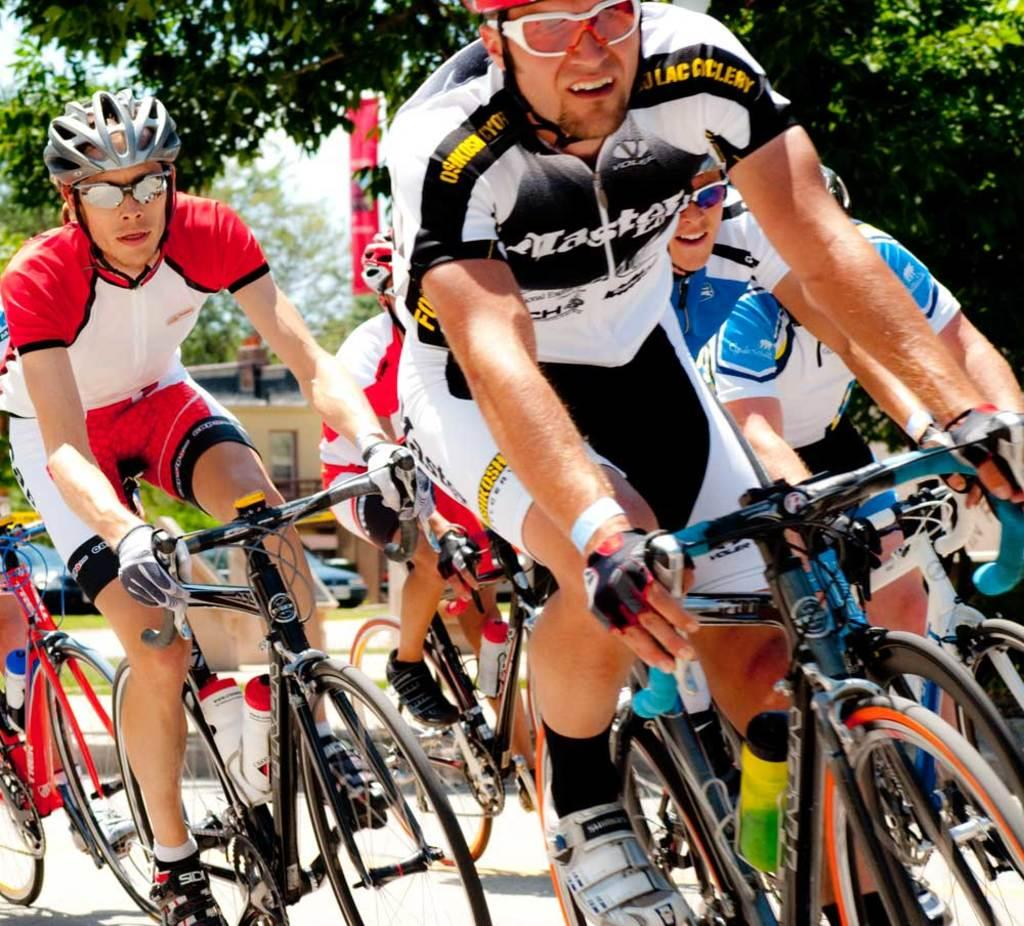What are the people in the image doing? The people in the image are riding bicycles. What might be the reason for the people riding bicycles? The people may be participating in a competition. What can be seen in the background of the image? There are trees in the background of the image, but they are blurry. What is the son of the person in the image thinking about while riding the bicycle? There is no information about a son or any thoughts of the people in the image, as the focus is on the group of people riding bicycles. 